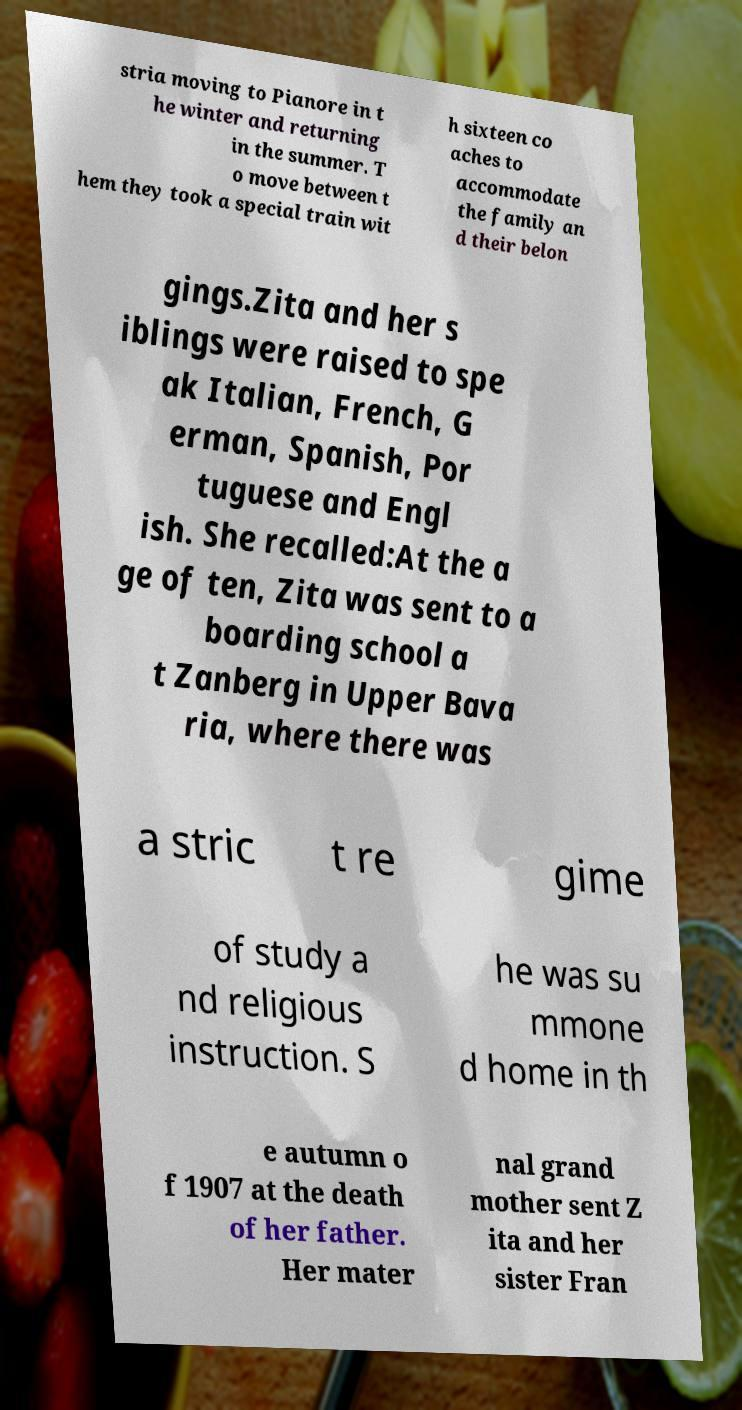Can you read and provide the text displayed in the image?This photo seems to have some interesting text. Can you extract and type it out for me? stria moving to Pianore in t he winter and returning in the summer. T o move between t hem they took a special train wit h sixteen co aches to accommodate the family an d their belon gings.Zita and her s iblings were raised to spe ak Italian, French, G erman, Spanish, Por tuguese and Engl ish. She recalled:At the a ge of ten, Zita was sent to a boarding school a t Zanberg in Upper Bava ria, where there was a stric t re gime of study a nd religious instruction. S he was su mmone d home in th e autumn o f 1907 at the death of her father. Her mater nal grand mother sent Z ita and her sister Fran 